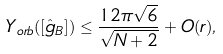Convert formula to latex. <formula><loc_0><loc_0><loc_500><loc_500>Y _ { o r b } ( [ \hat { g } _ { \L B } ] ) \leq \frac { 1 2 \pi \sqrt { 6 } } { \sqrt { N + 2 } } + O ( r ) ,</formula> 